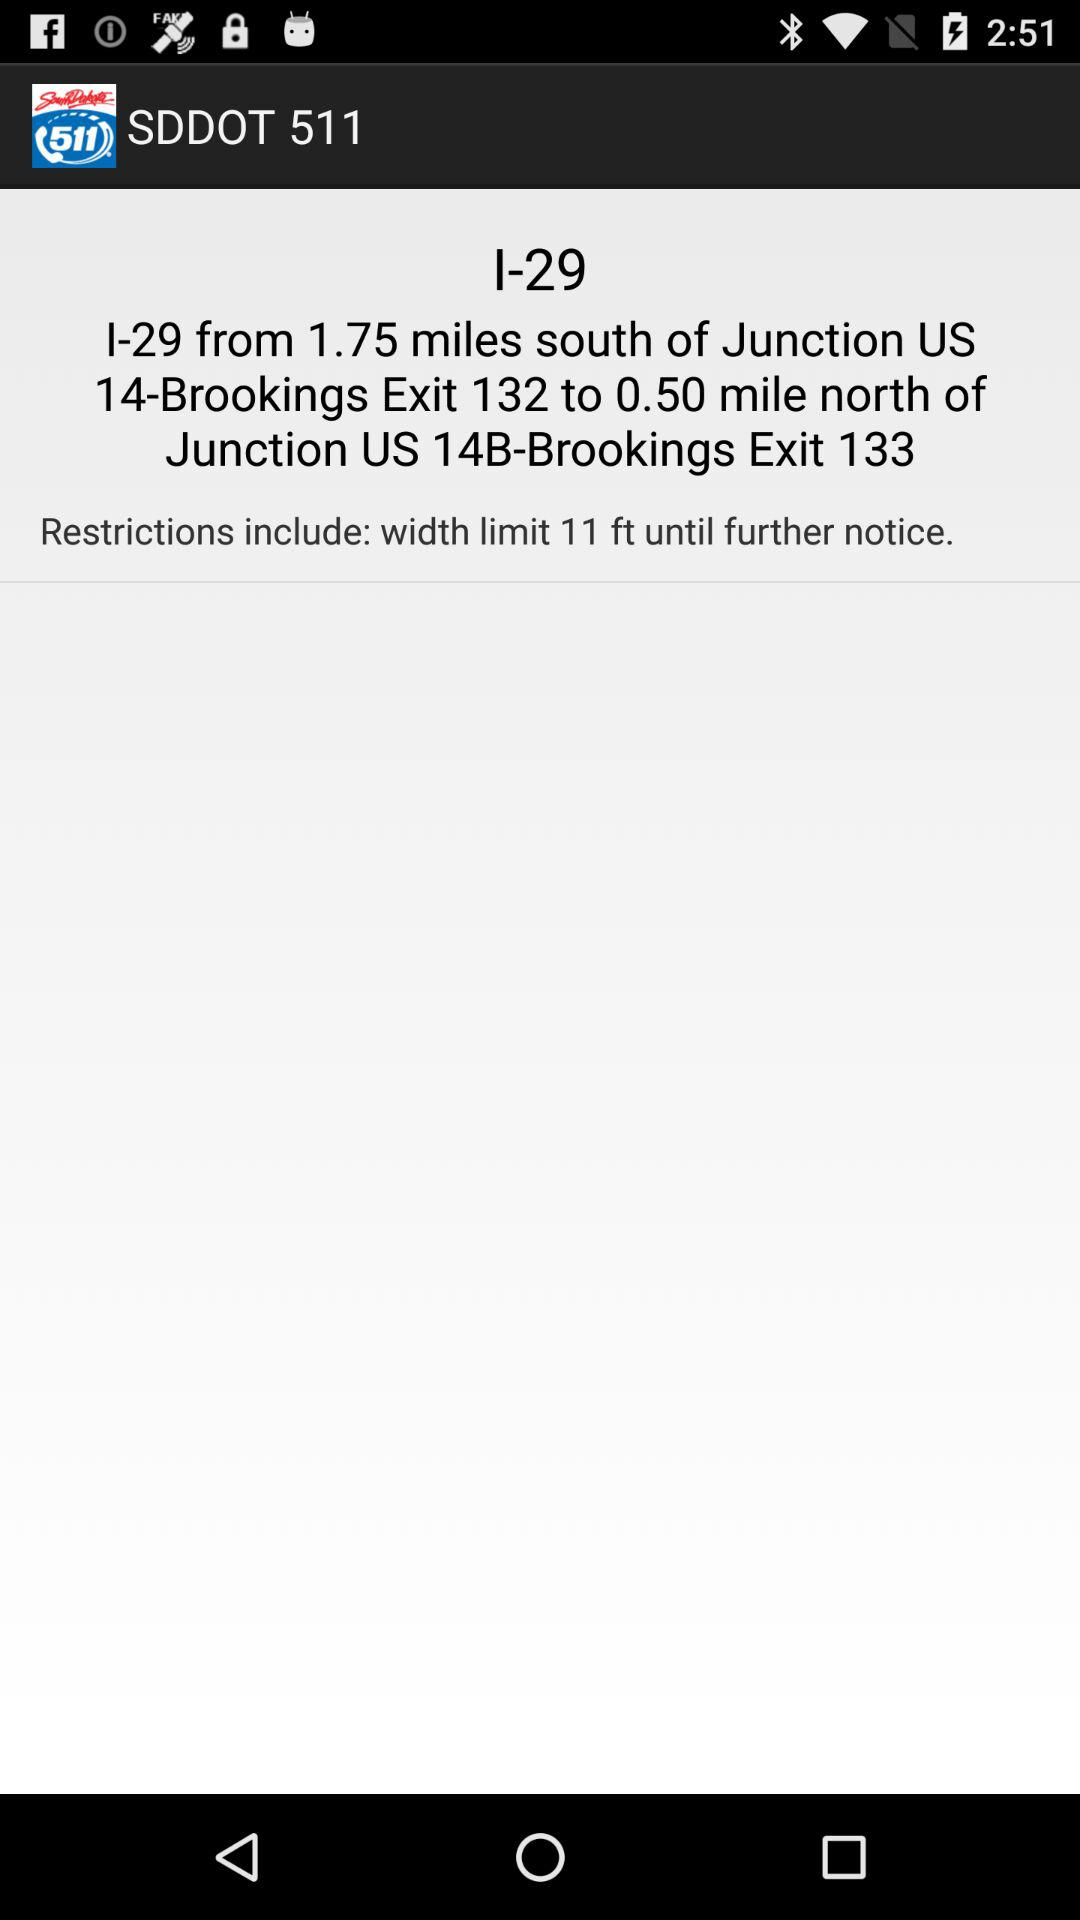What is the width limit for the restriction?
Answer the question using a single word or phrase. 11 ft 